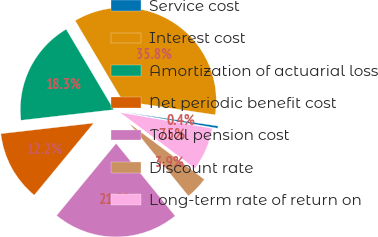Convert chart. <chart><loc_0><loc_0><loc_500><loc_500><pie_chart><fcel>Service cost<fcel>Interest cost<fcel>Amortization of actuarial loss<fcel>Net periodic benefit cost<fcel>Total pension cost<fcel>Discount rate<fcel>Long-term rate of return on<nl><fcel>0.38%<fcel>35.85%<fcel>18.31%<fcel>12.2%<fcel>21.85%<fcel>3.93%<fcel>7.48%<nl></chart> 